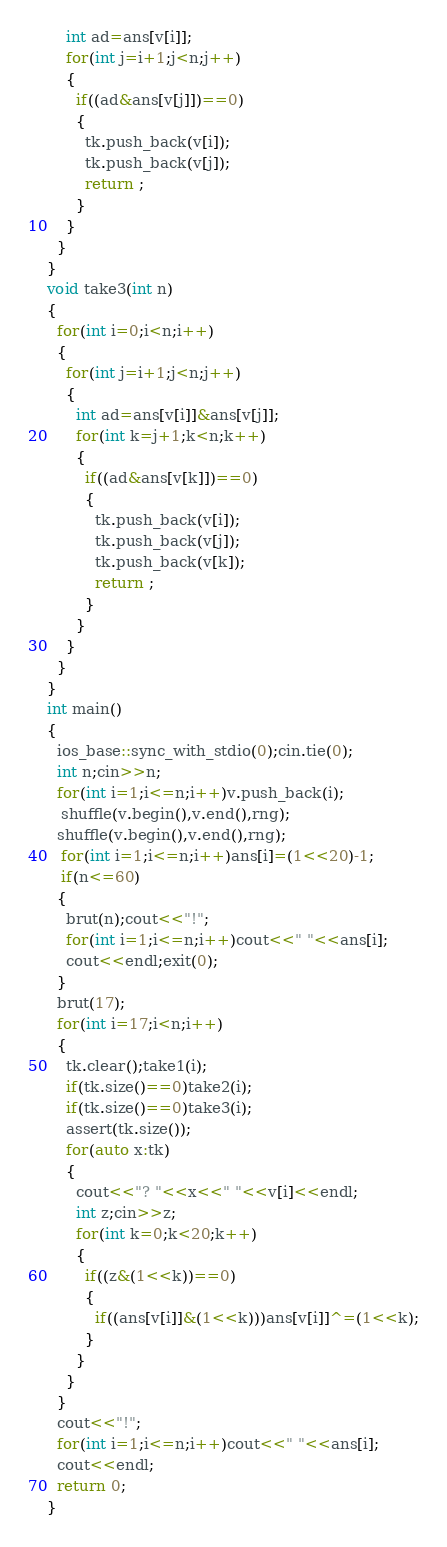<code> <loc_0><loc_0><loc_500><loc_500><_C++_>    int ad=ans[v[i]];
    for(int j=i+1;j<n;j++)
    {
      if((ad&ans[v[j]])==0)
      {
        tk.push_back(v[i]);
        tk.push_back(v[j]);
        return ;
      }
    }
  }
}
void take3(int n)
{
  for(int i=0;i<n;i++)
  {
    for(int j=i+1;j<n;j++)
    {
      int ad=ans[v[i]]&ans[v[j]];
      for(int k=j+1;k<n;k++)
      {
        if((ad&ans[v[k]])==0)
        {
          tk.push_back(v[i]);
          tk.push_back(v[j]);
          tk.push_back(v[k]);
          return ;
        }
      }
    }
  }
}
int main()
{
  ios_base::sync_with_stdio(0);cin.tie(0);
  int n;cin>>n;
  for(int i=1;i<=n;i++)v.push_back(i);
   shuffle(v.begin(),v.end(),rng);
  shuffle(v.begin(),v.end(),rng);
   for(int i=1;i<=n;i++)ans[i]=(1<<20)-1;
   if(n<=60)
  {
    brut(n);cout<<"!";
    for(int i=1;i<=n;i++)cout<<" "<<ans[i];
    cout<<endl;exit(0);
  }
  brut(17);
  for(int i=17;i<n;i++)
  {
    tk.clear();take1(i);
    if(tk.size()==0)take2(i);
    if(tk.size()==0)take3(i);
    assert(tk.size());
    for(auto x:tk)
    {
      cout<<"? "<<x<<" "<<v[i]<<endl;
      int z;cin>>z;
      for(int k=0;k<20;k++)
      {
        if((z&(1<<k))==0)
        {
          if((ans[v[i]]&(1<<k)))ans[v[i]]^=(1<<k);
        }
      }
    }
  }
  cout<<"!";
  for(int i=1;i<=n;i++)cout<<" "<<ans[i];
  cout<<endl;
  return 0;
}</code> 